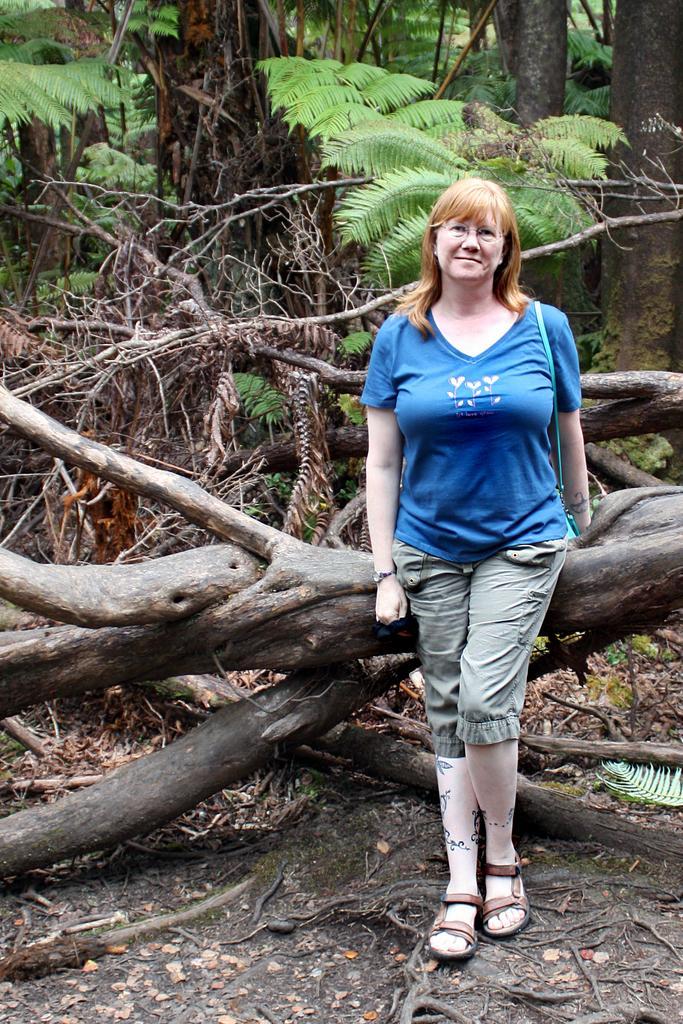Describe this image in one or two sentences. In the image there is a woman, she is standing in front of a log of a tree and in the background there are some other dry trees and plants. 